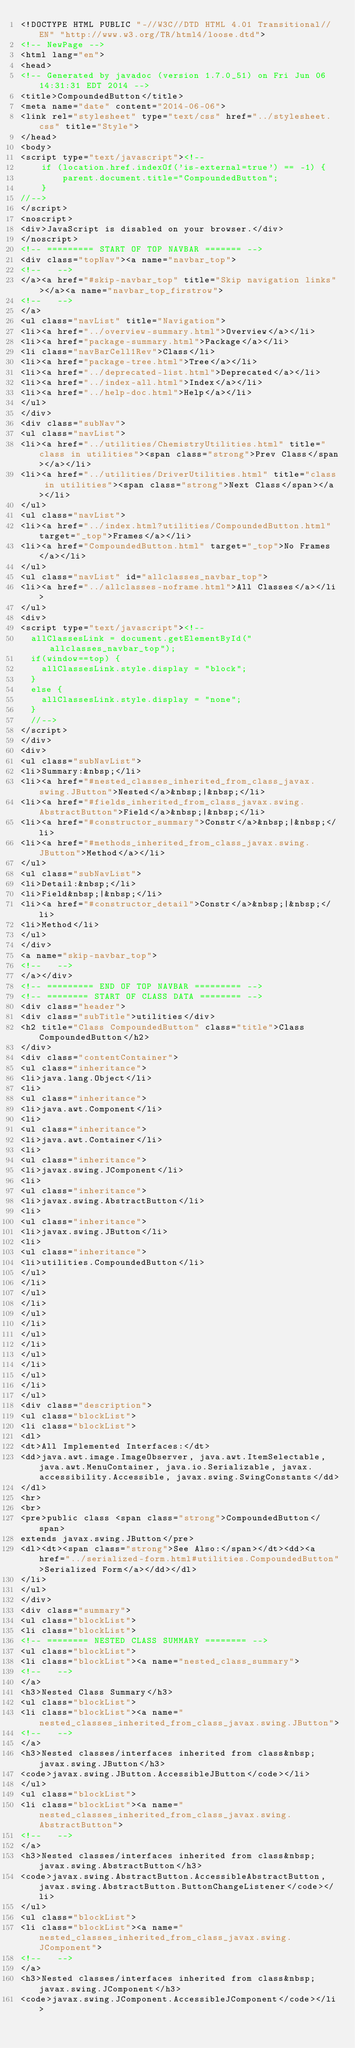Convert code to text. <code><loc_0><loc_0><loc_500><loc_500><_HTML_><!DOCTYPE HTML PUBLIC "-//W3C//DTD HTML 4.01 Transitional//EN" "http://www.w3.org/TR/html4/loose.dtd">
<!-- NewPage -->
<html lang="en">
<head>
<!-- Generated by javadoc (version 1.7.0_51) on Fri Jun 06 14:31:31 EDT 2014 -->
<title>CompoundedButton</title>
<meta name="date" content="2014-06-06">
<link rel="stylesheet" type="text/css" href="../stylesheet.css" title="Style">
</head>
<body>
<script type="text/javascript"><!--
    if (location.href.indexOf('is-external=true') == -1) {
        parent.document.title="CompoundedButton";
    }
//-->
</script>
<noscript>
<div>JavaScript is disabled on your browser.</div>
</noscript>
<!-- ========= START OF TOP NAVBAR ======= -->
<div class="topNav"><a name="navbar_top">
<!--   -->
</a><a href="#skip-navbar_top" title="Skip navigation links"></a><a name="navbar_top_firstrow">
<!--   -->
</a>
<ul class="navList" title="Navigation">
<li><a href="../overview-summary.html">Overview</a></li>
<li><a href="package-summary.html">Package</a></li>
<li class="navBarCell1Rev">Class</li>
<li><a href="package-tree.html">Tree</a></li>
<li><a href="../deprecated-list.html">Deprecated</a></li>
<li><a href="../index-all.html">Index</a></li>
<li><a href="../help-doc.html">Help</a></li>
</ul>
</div>
<div class="subNav">
<ul class="navList">
<li><a href="../utilities/ChemistryUtilities.html" title="class in utilities"><span class="strong">Prev Class</span></a></li>
<li><a href="../utilities/DriverUtilities.html" title="class in utilities"><span class="strong">Next Class</span></a></li>
</ul>
<ul class="navList">
<li><a href="../index.html?utilities/CompoundedButton.html" target="_top">Frames</a></li>
<li><a href="CompoundedButton.html" target="_top">No Frames</a></li>
</ul>
<ul class="navList" id="allclasses_navbar_top">
<li><a href="../allclasses-noframe.html">All Classes</a></li>
</ul>
<div>
<script type="text/javascript"><!--
  allClassesLink = document.getElementById("allclasses_navbar_top");
  if(window==top) {
    allClassesLink.style.display = "block";
  }
  else {
    allClassesLink.style.display = "none";
  }
  //-->
</script>
</div>
<div>
<ul class="subNavList">
<li>Summary:&nbsp;</li>
<li><a href="#nested_classes_inherited_from_class_javax.swing.JButton">Nested</a>&nbsp;|&nbsp;</li>
<li><a href="#fields_inherited_from_class_javax.swing.AbstractButton">Field</a>&nbsp;|&nbsp;</li>
<li><a href="#constructor_summary">Constr</a>&nbsp;|&nbsp;</li>
<li><a href="#methods_inherited_from_class_javax.swing.JButton">Method</a></li>
</ul>
<ul class="subNavList">
<li>Detail:&nbsp;</li>
<li>Field&nbsp;|&nbsp;</li>
<li><a href="#constructor_detail">Constr</a>&nbsp;|&nbsp;</li>
<li>Method</li>
</ul>
</div>
<a name="skip-navbar_top">
<!--   -->
</a></div>
<!-- ========= END OF TOP NAVBAR ========= -->
<!-- ======== START OF CLASS DATA ======== -->
<div class="header">
<div class="subTitle">utilities</div>
<h2 title="Class CompoundedButton" class="title">Class CompoundedButton</h2>
</div>
<div class="contentContainer">
<ul class="inheritance">
<li>java.lang.Object</li>
<li>
<ul class="inheritance">
<li>java.awt.Component</li>
<li>
<ul class="inheritance">
<li>java.awt.Container</li>
<li>
<ul class="inheritance">
<li>javax.swing.JComponent</li>
<li>
<ul class="inheritance">
<li>javax.swing.AbstractButton</li>
<li>
<ul class="inheritance">
<li>javax.swing.JButton</li>
<li>
<ul class="inheritance">
<li>utilities.CompoundedButton</li>
</ul>
</li>
</ul>
</li>
</ul>
</li>
</ul>
</li>
</ul>
</li>
</ul>
</li>
</ul>
<div class="description">
<ul class="blockList">
<li class="blockList">
<dl>
<dt>All Implemented Interfaces:</dt>
<dd>java.awt.image.ImageObserver, java.awt.ItemSelectable, java.awt.MenuContainer, java.io.Serializable, javax.accessibility.Accessible, javax.swing.SwingConstants</dd>
</dl>
<hr>
<br>
<pre>public class <span class="strong">CompoundedButton</span>
extends javax.swing.JButton</pre>
<dl><dt><span class="strong">See Also:</span></dt><dd><a href="../serialized-form.html#utilities.CompoundedButton">Serialized Form</a></dd></dl>
</li>
</ul>
</div>
<div class="summary">
<ul class="blockList">
<li class="blockList">
<!-- ======== NESTED CLASS SUMMARY ======== -->
<ul class="blockList">
<li class="blockList"><a name="nested_class_summary">
<!--   -->
</a>
<h3>Nested Class Summary</h3>
<ul class="blockList">
<li class="blockList"><a name="nested_classes_inherited_from_class_javax.swing.JButton">
<!--   -->
</a>
<h3>Nested classes/interfaces inherited from class&nbsp;javax.swing.JButton</h3>
<code>javax.swing.JButton.AccessibleJButton</code></li>
</ul>
<ul class="blockList">
<li class="blockList"><a name="nested_classes_inherited_from_class_javax.swing.AbstractButton">
<!--   -->
</a>
<h3>Nested classes/interfaces inherited from class&nbsp;javax.swing.AbstractButton</h3>
<code>javax.swing.AbstractButton.AccessibleAbstractButton, javax.swing.AbstractButton.ButtonChangeListener</code></li>
</ul>
<ul class="blockList">
<li class="blockList"><a name="nested_classes_inherited_from_class_javax.swing.JComponent">
<!--   -->
</a>
<h3>Nested classes/interfaces inherited from class&nbsp;javax.swing.JComponent</h3>
<code>javax.swing.JComponent.AccessibleJComponent</code></li></code> 